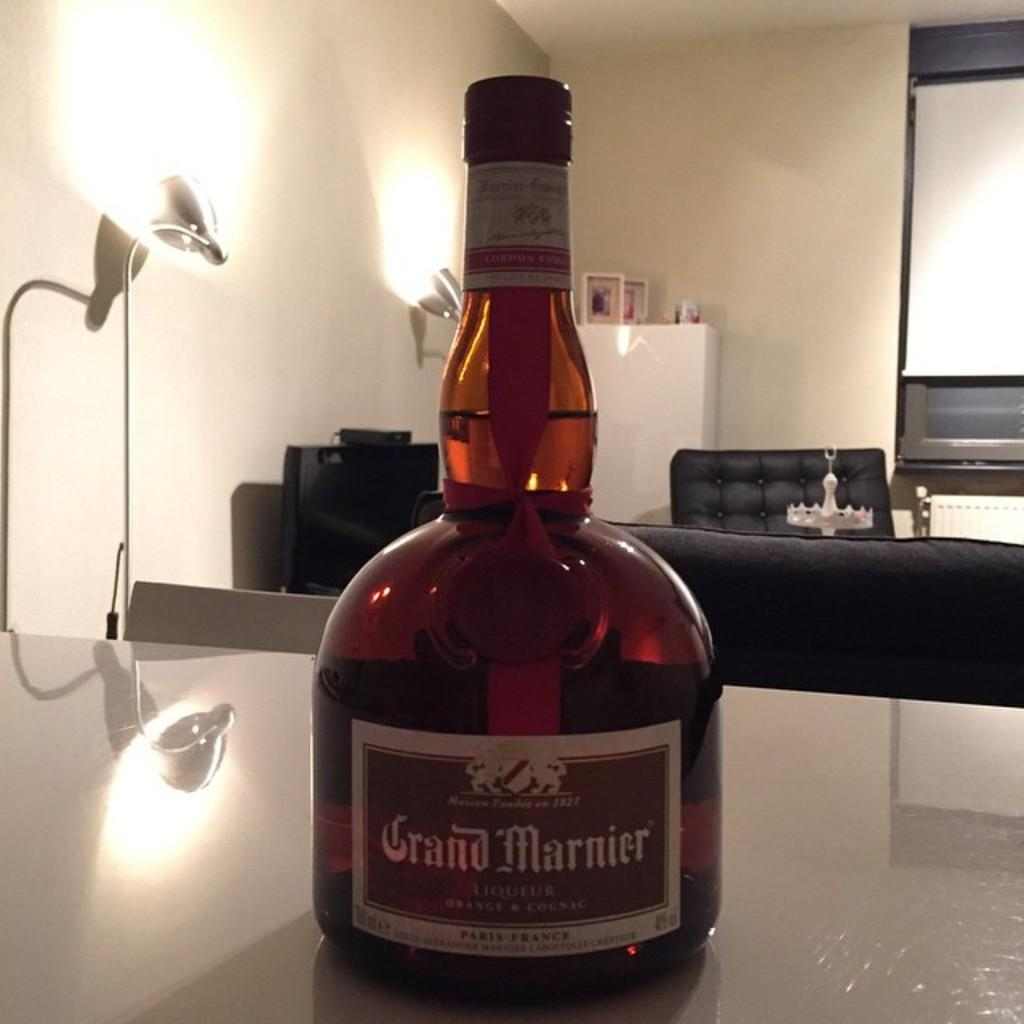<image>
Share a concise interpretation of the image provided. A bottle of Grand Marnier is on a counter 